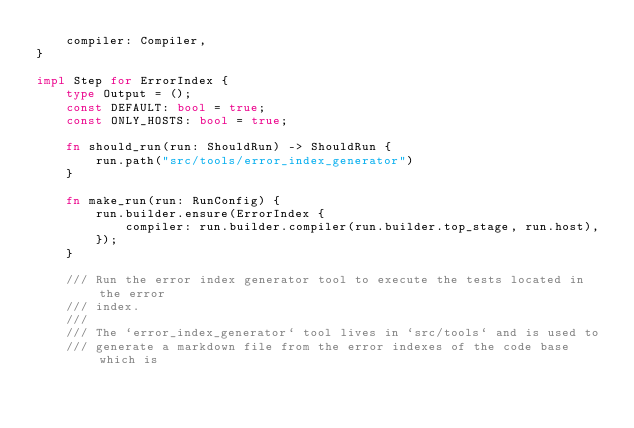<code> <loc_0><loc_0><loc_500><loc_500><_Rust_>    compiler: Compiler,
}

impl Step for ErrorIndex {
    type Output = ();
    const DEFAULT: bool = true;
    const ONLY_HOSTS: bool = true;

    fn should_run(run: ShouldRun) -> ShouldRun {
        run.path("src/tools/error_index_generator")
    }

    fn make_run(run: RunConfig) {
        run.builder.ensure(ErrorIndex {
            compiler: run.builder.compiler(run.builder.top_stage, run.host),
        });
    }

    /// Run the error index generator tool to execute the tests located in the error
    /// index.
    ///
    /// The `error_index_generator` tool lives in `src/tools` and is used to
    /// generate a markdown file from the error indexes of the code base which is</code> 